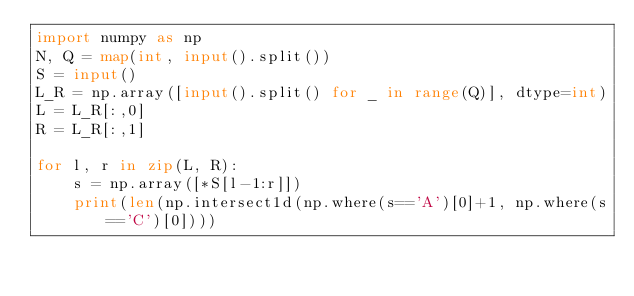<code> <loc_0><loc_0><loc_500><loc_500><_Python_>import numpy as np
N, Q = map(int, input().split())
S = input()
L_R = np.array([input().split() for _ in range(Q)], dtype=int)
L = L_R[:,0]
R = L_R[:,1]

for l, r in zip(L, R):
    s = np.array([*S[l-1:r]])
    print(len(np.intersect1d(np.where(s=='A')[0]+1, np.where(s=='C')[0])))</code> 